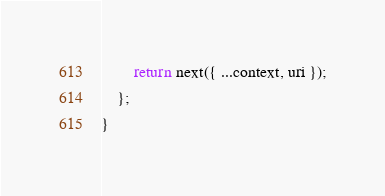<code> <loc_0><loc_0><loc_500><loc_500><_TypeScript_>        return next({ ...context, uri });
    };
}
</code> 